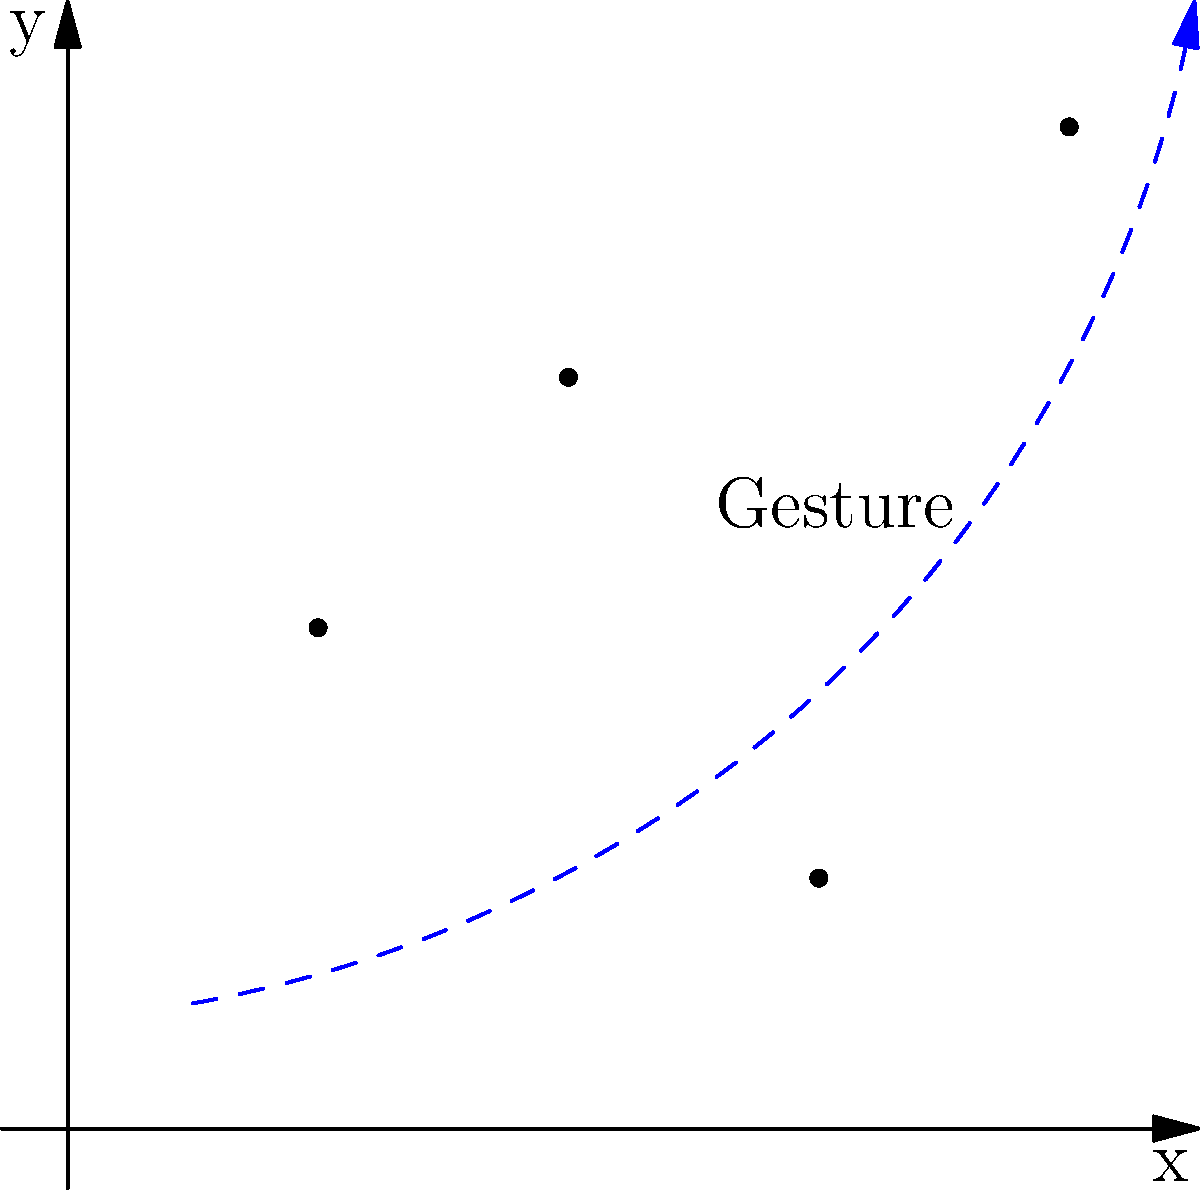In designing an interactive scatter plot using Flutter's coordinate system and gestures, which gesture would be most appropriate for implementing a "zoom" functionality on the plot shown above? To implement a zoom functionality for an interactive scatter plot in Flutter, we need to consider the following steps:

1. Understand the coordinate system: The scatter plot is displayed on a 2D coordinate system with x and y axes.

2. Analyze the data points: The plot shows four data points at coordinates (1,2), (2,3), (3,1), and (4,4).

3. Consider user interaction: The goal is to allow users to zoom in or out of the plot.

4. Evaluate gesture options:
   a. Tap: Not suitable for zooming as it's typically used for selection.
   b. Single-finger drag: Usually used for panning the plot.
   c. Pinch: Involves two fingers moving towards or away from each other.
   d. Double-tap: Could be used for a fixed zoom level, but lacks fine control.

5. Choose the most appropriate gesture: The pinch gesture is the most intuitive and widely used for zooming in mobile and web applications. It allows for smooth, continuous zooming with fine control.

6. Implementation in Flutter:
   - Use the `GestureDetector` widget to wrap the scatter plot.
   - Implement the `onScaleUpdate` callback to handle the pinch gesture.
   - Update the plot's scale factor based on the gesture's scale property.
   - Redraw the scatter plot with the new scale factor.

Given the interactive nature of the task and the need for precise control over the zoom level, the pinch gesture is the most appropriate choice for implementing zoom functionality on this scatter plot.
Answer: Pinch gesture 